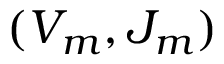<formula> <loc_0><loc_0><loc_500><loc_500>( V _ { m } , J _ { m } )</formula> 